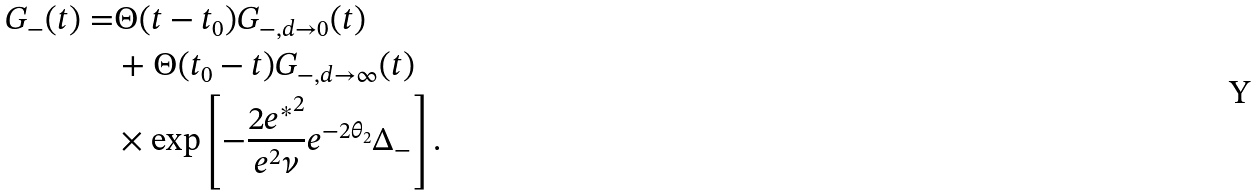<formula> <loc_0><loc_0><loc_500><loc_500>G _ { - } ( t ) = & \Theta ( t - t _ { 0 } ) G _ { - , d \to 0 } ( t ) \\ & + \Theta ( t _ { 0 } - t ) G _ { - , d \to \infty } ( t ) \\ & \times \exp \left [ - \frac { 2 { e ^ { * } } ^ { 2 } } { e ^ { 2 } \nu } e ^ { - 2 \theta _ { 2 } } \Delta _ { - } \right ] .</formula> 